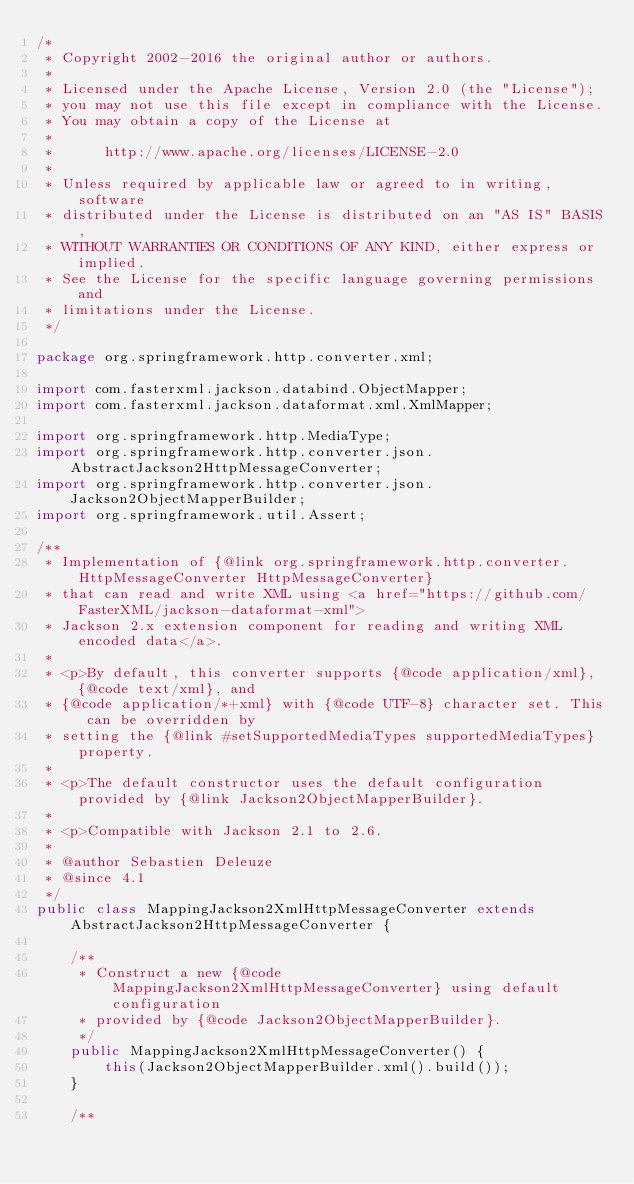<code> <loc_0><loc_0><loc_500><loc_500><_Java_>/*
 * Copyright 2002-2016 the original author or authors.
 *
 * Licensed under the Apache License, Version 2.0 (the "License");
 * you may not use this file except in compliance with the License.
 * You may obtain a copy of the License at
 *
 *      http://www.apache.org/licenses/LICENSE-2.0
 *
 * Unless required by applicable law or agreed to in writing, software
 * distributed under the License is distributed on an "AS IS" BASIS,
 * WITHOUT WARRANTIES OR CONDITIONS OF ANY KIND, either express or implied.
 * See the License for the specific language governing permissions and
 * limitations under the License.
 */

package org.springframework.http.converter.xml;

import com.fasterxml.jackson.databind.ObjectMapper;
import com.fasterxml.jackson.dataformat.xml.XmlMapper;

import org.springframework.http.MediaType;
import org.springframework.http.converter.json.AbstractJackson2HttpMessageConverter;
import org.springframework.http.converter.json.Jackson2ObjectMapperBuilder;
import org.springframework.util.Assert;

/**
 * Implementation of {@link org.springframework.http.converter.HttpMessageConverter HttpMessageConverter}
 * that can read and write XML using <a href="https://github.com/FasterXML/jackson-dataformat-xml">
 * Jackson 2.x extension component for reading and writing XML encoded data</a>.
 *
 * <p>By default, this converter supports {@code application/xml}, {@code text/xml}, and
 * {@code application/*+xml} with {@code UTF-8} character set. This can be overridden by
 * setting the {@link #setSupportedMediaTypes supportedMediaTypes} property.
 *
 * <p>The default constructor uses the default configuration provided by {@link Jackson2ObjectMapperBuilder}.
 *
 * <p>Compatible with Jackson 2.1 to 2.6.
 *
 * @author Sebastien Deleuze
 * @since 4.1
 */
public class MappingJackson2XmlHttpMessageConverter extends AbstractJackson2HttpMessageConverter {

	/**
	 * Construct a new {@code MappingJackson2XmlHttpMessageConverter} using default configuration
	 * provided by {@code Jackson2ObjectMapperBuilder}.
	 */
	public MappingJackson2XmlHttpMessageConverter() {
		this(Jackson2ObjectMapperBuilder.xml().build());
	}

	/**</code> 